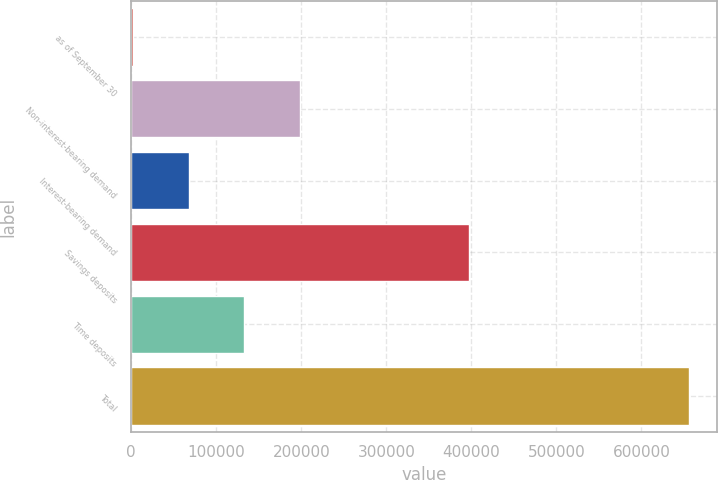<chart> <loc_0><loc_0><loc_500><loc_500><bar_chart><fcel>as of September 30<fcel>Non-interest-bearing demand<fcel>Interest-bearing demand<fcel>Savings deposits<fcel>Time deposits<fcel>Total<nl><fcel>2010<fcel>198131<fcel>67383.8<fcel>397078<fcel>132758<fcel>655748<nl></chart> 